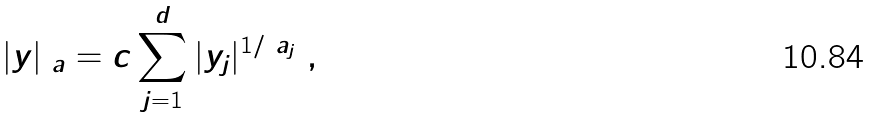<formula> <loc_0><loc_0><loc_500><loc_500>| y | _ { \ a } = c \sum _ { j = 1 } ^ { d } | y _ { j } | ^ { 1 / \ a _ { j } } \ ,</formula> 